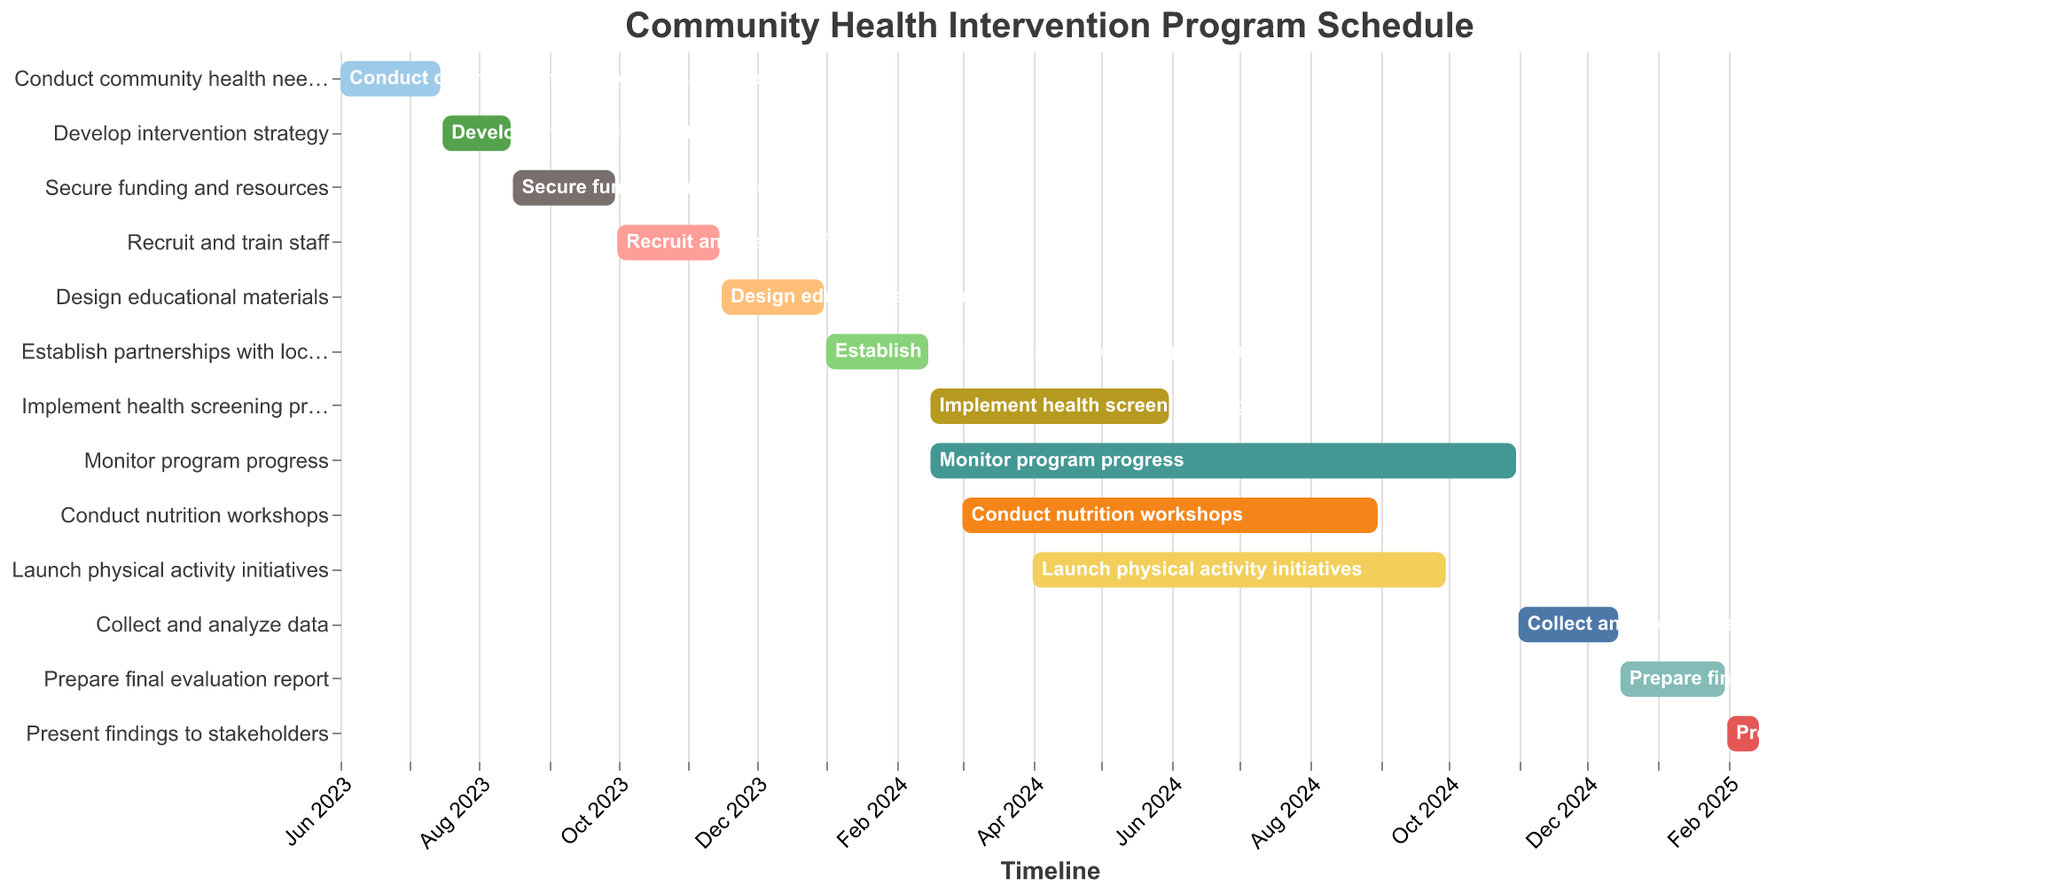What is the duration of the "Develop intervention strategy" task? The duration of the "Develop intervention strategy" task is listed as one of the fields in the figure. Locate that task and read its corresponding duration value.
Answer: 31 days How many tasks are scheduled to start in the year 2024? To find out how many tasks are scheduled to start in 2024, visually scan the start dates of all tasks in the figure and count those that fall within the year 2024.
Answer: 5 tasks Which task has the longest duration and what is its duration? To identify the task with the longest duration, compare the duration fields of all tasks. The task with the highest duration value is the one with the longest duration.
Answer: "Monitor program progress" with 259 days When does the "Launch physical activity initiatives" task end? Locate the "Launch physical activity initiatives" task in the figure and read its corresponding End Date value.
Answer: 2024-09-30 How much time is there between the end of "Recruit and train staff" and the start of "Design educational materials"? Find the End Date of "Recruit and train staff" and the Start Date of "Design educational materials". Calculate the number of days between these two dates.
Answer: 1 day Which task starts immediately after "Secure funding and resources"? Identify the End Date of "Secure funding and resources" and find the task whose Start Date is the next chronological date.
Answer: "Recruit and train staff" What is the total duration of all tasks beginning in 2023? Locate all tasks that start in 2023, and sum their duration values: (45 + 31 + 46 + 46 + 46).
Answer: 214 days Are there any tasks that overlap with the "Implement health screening program"? Check the start and end dates of the "Implement health screening program" and compare them with the other tasks to see if any task's date range overlaps with this program.
Answer: Yes, "Conduct nutrition workshops", "Launch physical activity initiatives", and "Monitor program progress" What is the final task in the schedule, and when does it end? The final task in the schedule is listed last chronologically in the Gantt chart. Identify this task and its End Date.
Answer: "Present findings to stakeholders" on 2025-02-15 